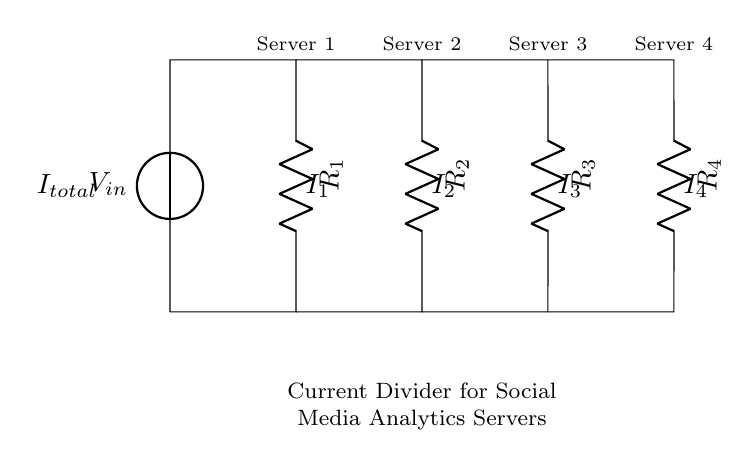What is the type of circuit shown in the diagram? The circuit is a current divider, as it divides the input current among multiple branches connected in parallel.
Answer: Current Divider How many servers are connected in this circuit? Four resistors represent four servers, each connected to a branch of the current division circuit.
Answer: Four What is the total input current labeled in the circuit? The total current flowing into the circuit is labeled as I total, denoting the combined input current before it is divided among the branches.
Answer: I total What do the labels R1, R2, R3, and R4 represent? These labels represent the resistors connected in parallel, which affect how the input current divides among the servers.
Answer: Resistors How does the current I1 compare to the total current I total in the circuit? The current I1 is a fraction of the total current and is determined by the resistance value R1 compared to the total parallel resistance of the circuit.
Answer: Fraction of I total Which server gets the highest current if all resistances are equal? If all resistances are equal, each server will receive equal current, meaning no single server will have the highest current; they share it equally.
Answer: Equal current Which server would get the least current if R3 has a higher resistance than the others? If R3 has a higher resistance, server 3 connected to R3 would receive the least current because higher resistance results in less current flow in a current divider.
Answer: Server 3 